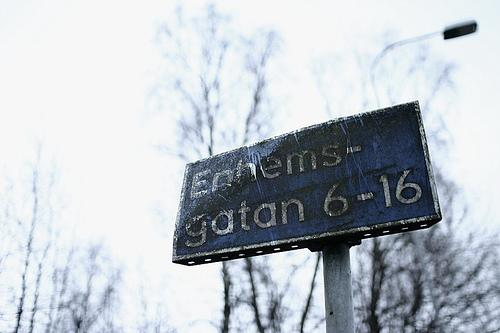In the image, what type of sign is attached to the pole? A blue and white direction sign is attached to the pole. Evaluate the overall sentiment or mood of the image. The image has a neutral sentiment, as it primarily consists of everyday objects like signs and tree branches with no strong emotional content. Based on the image, comment on the number of white letters present on the blue and white sign. There are 10 white letters present on the blue and white sign. What is the color and shape of the sign with white numbers on it? The sign with white numbers is blue and rectangular in shape. How many tree branches are visible in the image? There are 13 visible tree branches in the image. From the image, determine the number of visible street lights. There is one visible street light in the image. Provide a brief description of the most prominent object in the image. A blue and white direction sign is mounted on a silver post and displays various letters and numbers, surrounded by tree branches. List three distinct elements that can be observed within the image. Direction sign, tree branches, and street light. Perform a reasoning task by assessing the possible location where this image could have been captured. The image could have been captured at an intersection in an urban or suburban area, where a direction sign is mounted on a pole near tree branches and a street light. In this image, analyze the relationship between the direction sign and the surrounding objects. The direction sign is the main focal point, surrounded by tree branches and a street light, creating a sense of an urban or suburban setting. Briefly describe the appearance and placement of the bolts in the image. White bolts placed at the bottom of the sign Examine the image and identify any numbers present on the sign. Numbers 1 and 6 Describe the appearance of the branches on the tree in the image. There are multiple branches with varying sizes scattered throughout the tree. In the image, locate and explain the appearance of the blue and white sign. The blue and white sign is rectangular with a white border, attached to a silver post. Based on your understanding of the image, can you create a diagram animation, showcasing the key elements of the image? A diagram animation, highlighting sign on a pole, tree branches, and street light From the information provided, imagine a scene of the image, and describe it briefly. A street scene featuring a blue and white directional sign on a pole near a tree with multiple branches, and a street light in the sky. What object is attached to the pole in the image? A sign Is there a yellow street sign in the image? No, it's not mentioned in the image. What emotion would you associate with this image? Neutral Which letters are on the sign and in what order? E, N, H, M, S, G, A, T What is the primary object visible in the sky in the image? Street light Estimate the total number of tree branches visible in the image. 14 What is the primary activity occurring around the sign on a pole? Providing directions or information Identify the main event depicted in the image. Directional sign on a pole beside a tree Based on the information provided, did you see a street light attached to a pole in the image? Yes Describe the relationship between the sign and tree branches in the image. The sign is nearby the tree with multiple branches Describe the primary color and shape of the sign on the pole in the image. Blue and rectangular Which of the following is an object in the top left corner of the sign on the pole: blue and white rectangle, white number 1, yellow triangle, green circle? Blue and white rectangle Identify the position and color of the letters on the sign. White letters are positioned on a blue background. 